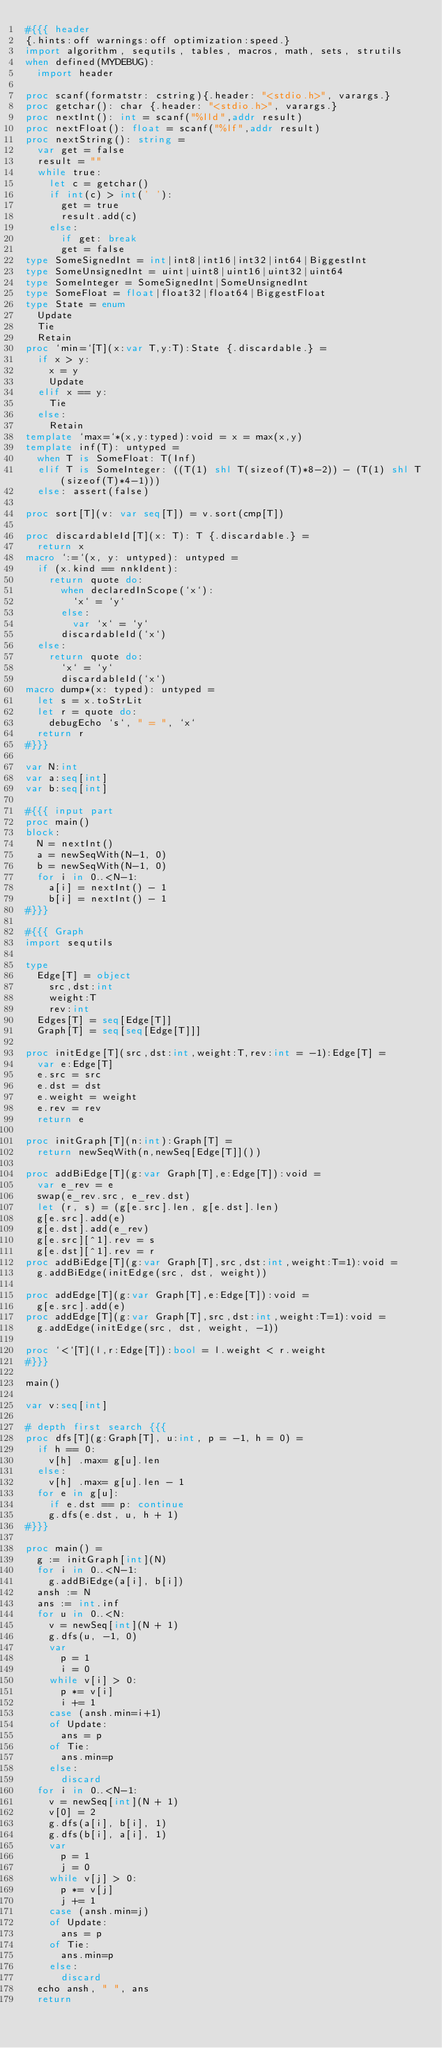<code> <loc_0><loc_0><loc_500><loc_500><_Nim_>#{{{ header
{.hints:off warnings:off optimization:speed.}
import algorithm, sequtils, tables, macros, math, sets, strutils
when defined(MYDEBUG):
  import header

proc scanf(formatstr: cstring){.header: "<stdio.h>", varargs.}
proc getchar(): char {.header: "<stdio.h>", varargs.}
proc nextInt(): int = scanf("%lld",addr result)
proc nextFloat(): float = scanf("%lf",addr result)
proc nextString(): string =
  var get = false
  result = ""
  while true:
    let c = getchar()
    if int(c) > int(' '):
      get = true
      result.add(c)
    else:
      if get: break
      get = false
type SomeSignedInt = int|int8|int16|int32|int64|BiggestInt
type SomeUnsignedInt = uint|uint8|uint16|uint32|uint64
type SomeInteger = SomeSignedInt|SomeUnsignedInt
type SomeFloat = float|float32|float64|BiggestFloat
type State = enum
  Update
  Tie
  Retain
proc `min=`[T](x:var T,y:T):State {.discardable.} =
  if x > y:
    x = y
    Update
  elif x == y:
    Tie
  else:
    Retain
template `max=`*(x,y:typed):void = x = max(x,y)
template inf(T): untyped = 
  when T is SomeFloat: T(Inf)
  elif T is SomeInteger: ((T(1) shl T(sizeof(T)*8-2)) - (T(1) shl T(sizeof(T)*4-1)))
  else: assert(false)

proc sort[T](v: var seq[T]) = v.sort(cmp[T])

proc discardableId[T](x: T): T {.discardable.} =
  return x
macro `:=`(x, y: untyped): untyped =
  if (x.kind == nnkIdent):
    return quote do:
      when declaredInScope(`x`):
        `x` = `y`
      else:
        var `x` = `y`
      discardableId(`x`)
  else:
    return quote do:
      `x` = `y`
      discardableId(`x`)
macro dump*(x: typed): untyped =
  let s = x.toStrLit
  let r = quote do:
    debugEcho `s`, " = ", `x`
  return r
#}}}

var N:int
var a:seq[int]
var b:seq[int]

#{{{ input part
proc main()
block:
  N = nextInt()
  a = newSeqWith(N-1, 0)
  b = newSeqWith(N-1, 0)
  for i in 0..<N-1:
    a[i] = nextInt() - 1
    b[i] = nextInt() - 1
#}}}

#{{{ Graph
import sequtils

type
  Edge[T] = object
    src,dst:int
    weight:T
    rev:int
  Edges[T] = seq[Edge[T]]
  Graph[T] = seq[seq[Edge[T]]]

proc initEdge[T](src,dst:int,weight:T,rev:int = -1):Edge[T] =
  var e:Edge[T]
  e.src = src
  e.dst = dst
  e.weight = weight
  e.rev = rev
  return e

proc initGraph[T](n:int):Graph[T] =
  return newSeqWith(n,newSeq[Edge[T]]())

proc addBiEdge[T](g:var Graph[T],e:Edge[T]):void =
  var e_rev = e
  swap(e_rev.src, e_rev.dst)
  let (r, s) = (g[e.src].len, g[e.dst].len)
  g[e.src].add(e)
  g[e.dst].add(e_rev)
  g[e.src][^1].rev = s
  g[e.dst][^1].rev = r
proc addBiEdge[T](g:var Graph[T],src,dst:int,weight:T=1):void =
  g.addBiEdge(initEdge(src, dst, weight))

proc addEdge[T](g:var Graph[T],e:Edge[T]):void =
  g[e.src].add(e)
proc addEdge[T](g:var Graph[T],src,dst:int,weight:T=1):void =
  g.addEdge(initEdge(src, dst, weight, -1))

proc `<`[T](l,r:Edge[T]):bool = l.weight < r.weight
#}}}

main()

var v:seq[int]

# depth first search {{{
proc dfs[T](g:Graph[T], u:int, p = -1, h = 0) =
  if h == 0:
    v[h] .max= g[u].len
  else:
    v[h] .max= g[u].len - 1
  for e in g[u]:
    if e.dst == p: continue
    g.dfs(e.dst, u, h + 1)
#}}}

proc main() =
  g := initGraph[int](N)
  for i in 0..<N-1:
    g.addBiEdge(a[i], b[i])
  ansh := N
  ans := int.inf
  for u in 0..<N:
    v = newSeq[int](N + 1)
    g.dfs(u, -1, 0)
    var
      p = 1
      i = 0
    while v[i] > 0:
      p *= v[i]
      i += 1
    case (ansh.min=i+1)
    of Update:
      ans = p
    of Tie:
      ans.min=p
    else:
      discard
  for i in 0..<N-1:
    v = newSeq[int](N + 1)
    v[0] = 2
    g.dfs(a[i], b[i], 1)
    g.dfs(b[i], a[i], 1)
    var
      p = 1
      j = 0
    while v[j] > 0:
      p *= v[j]
      j += 1
    case (ansh.min=j)
    of Update:
      ans = p
    of Tie:
      ans.min=p
    else:
      discard
  echo ansh, " ", ans
  return
</code> 